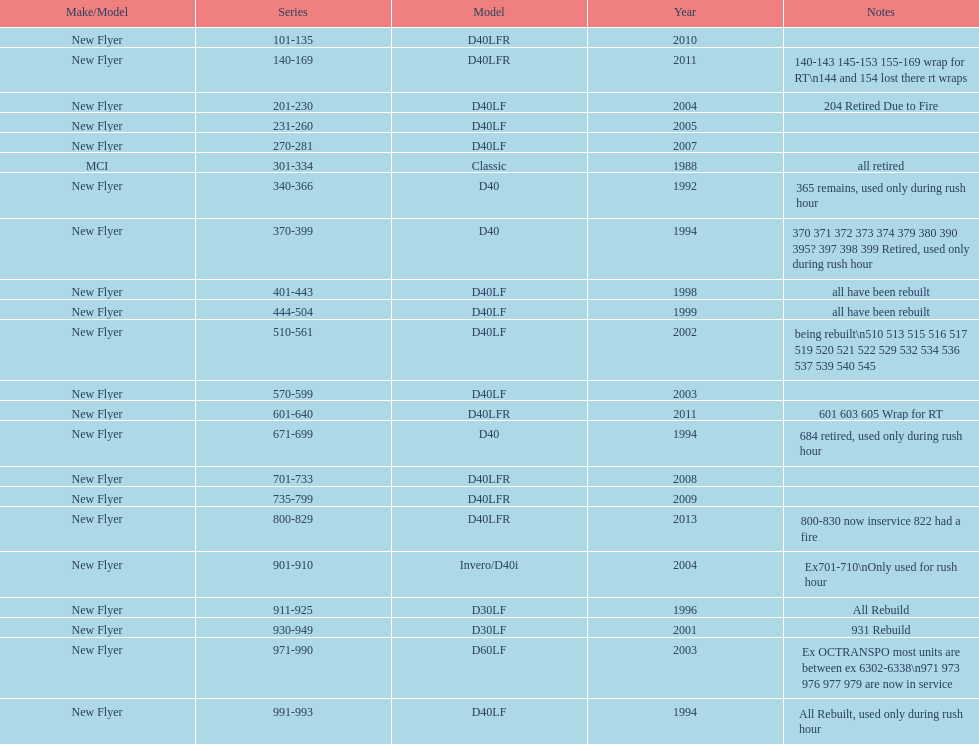Which buses are the latest in the present fleet? 800-829. 